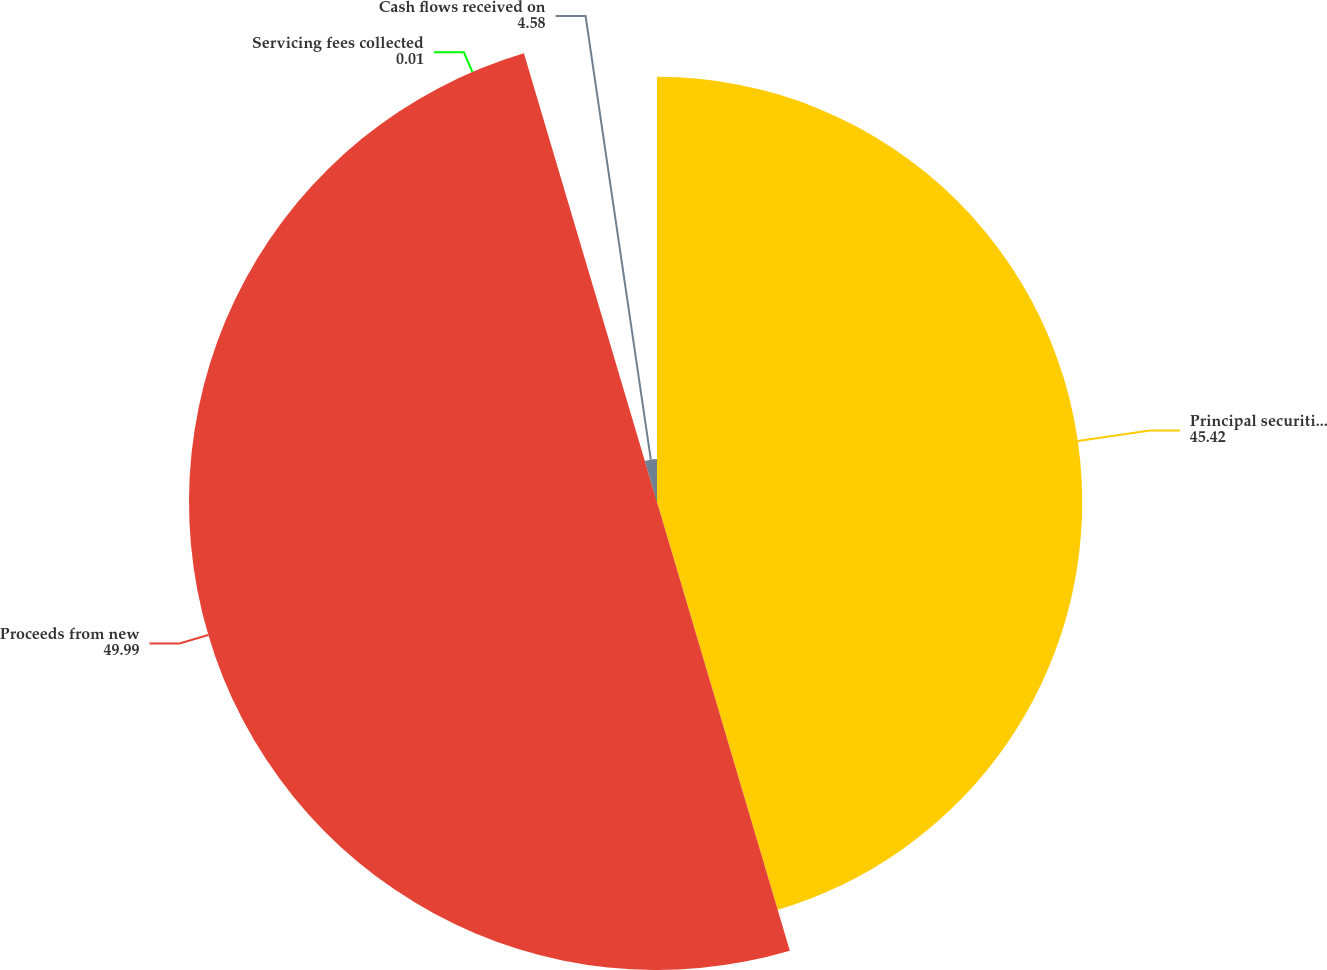Convert chart to OTSL. <chart><loc_0><loc_0><loc_500><loc_500><pie_chart><fcel>Principal securitized<fcel>Proceeds from new<fcel>Servicing fees collected<fcel>Cash flows received on<nl><fcel>45.42%<fcel>49.99%<fcel>0.01%<fcel>4.58%<nl></chart> 